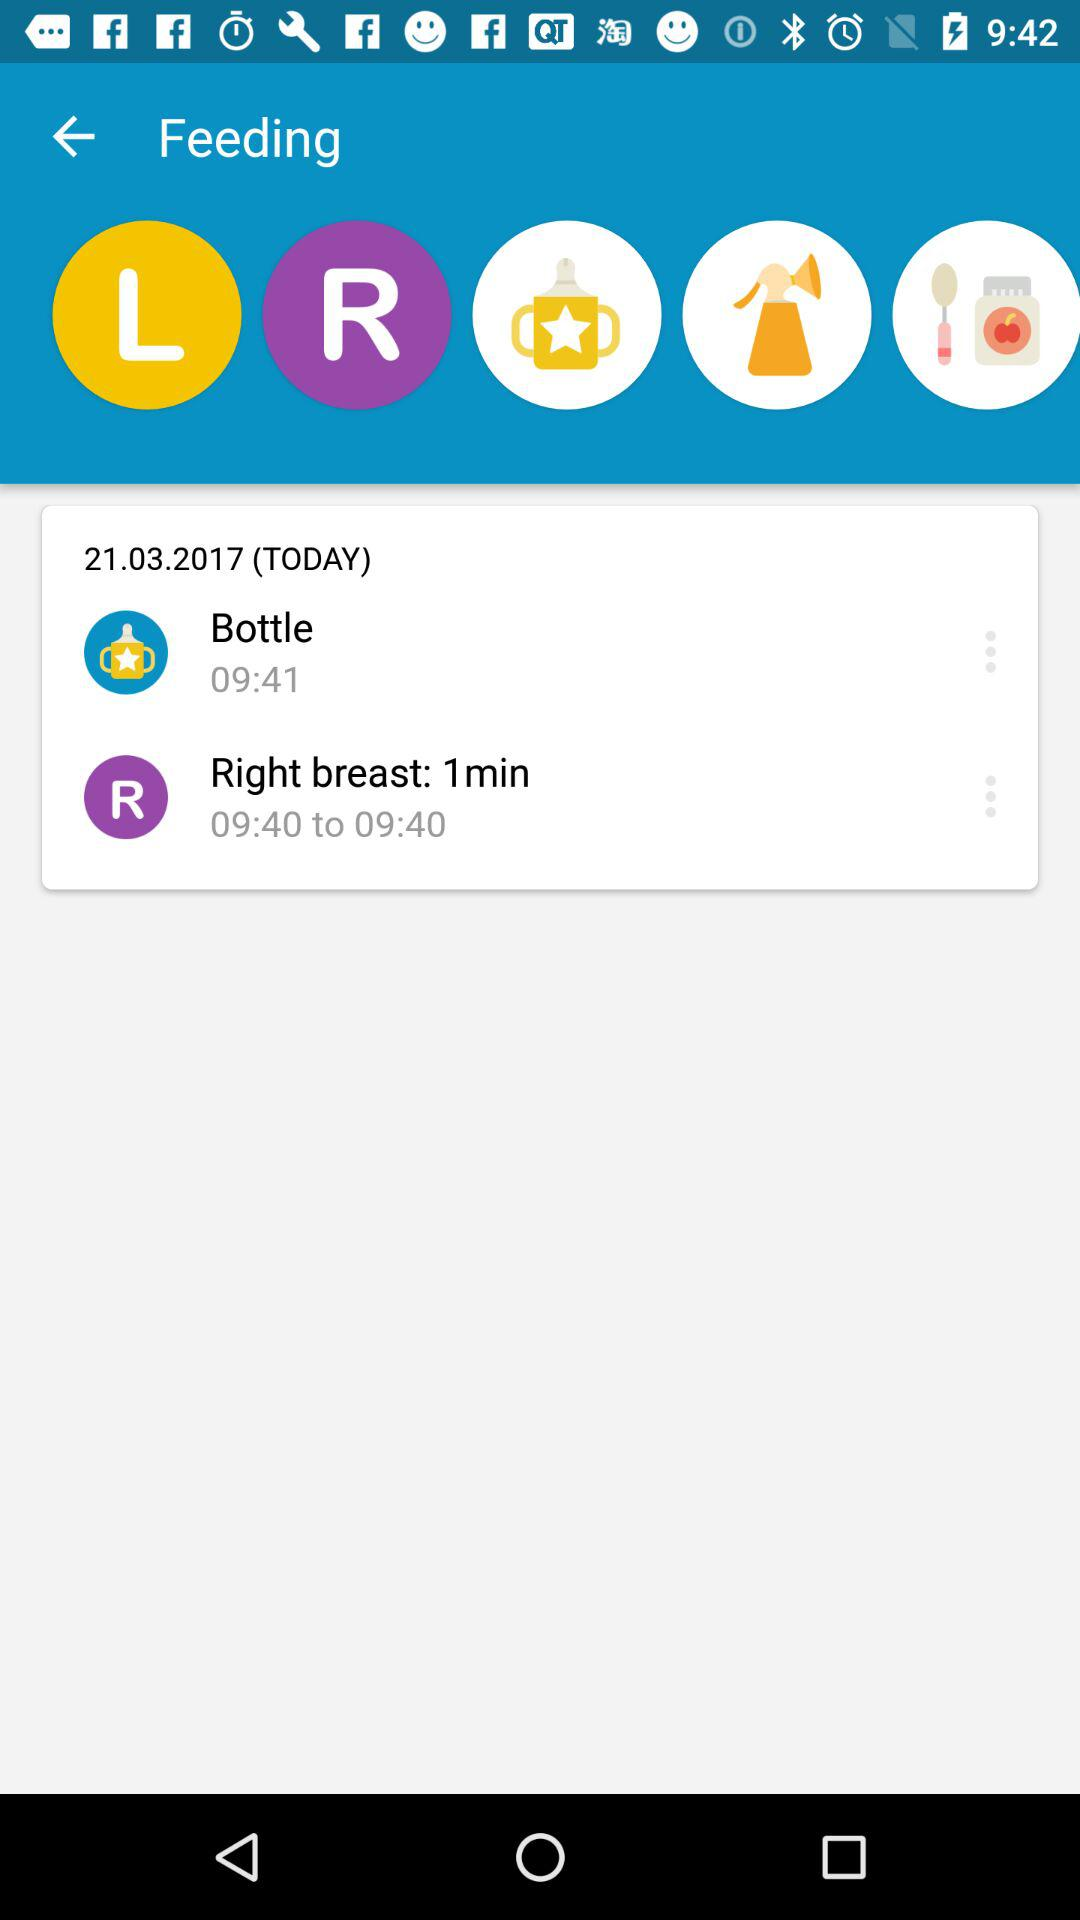What is the duration of "Right breast" feeding? The duration of "Right breast" feeding is 1 minute. 